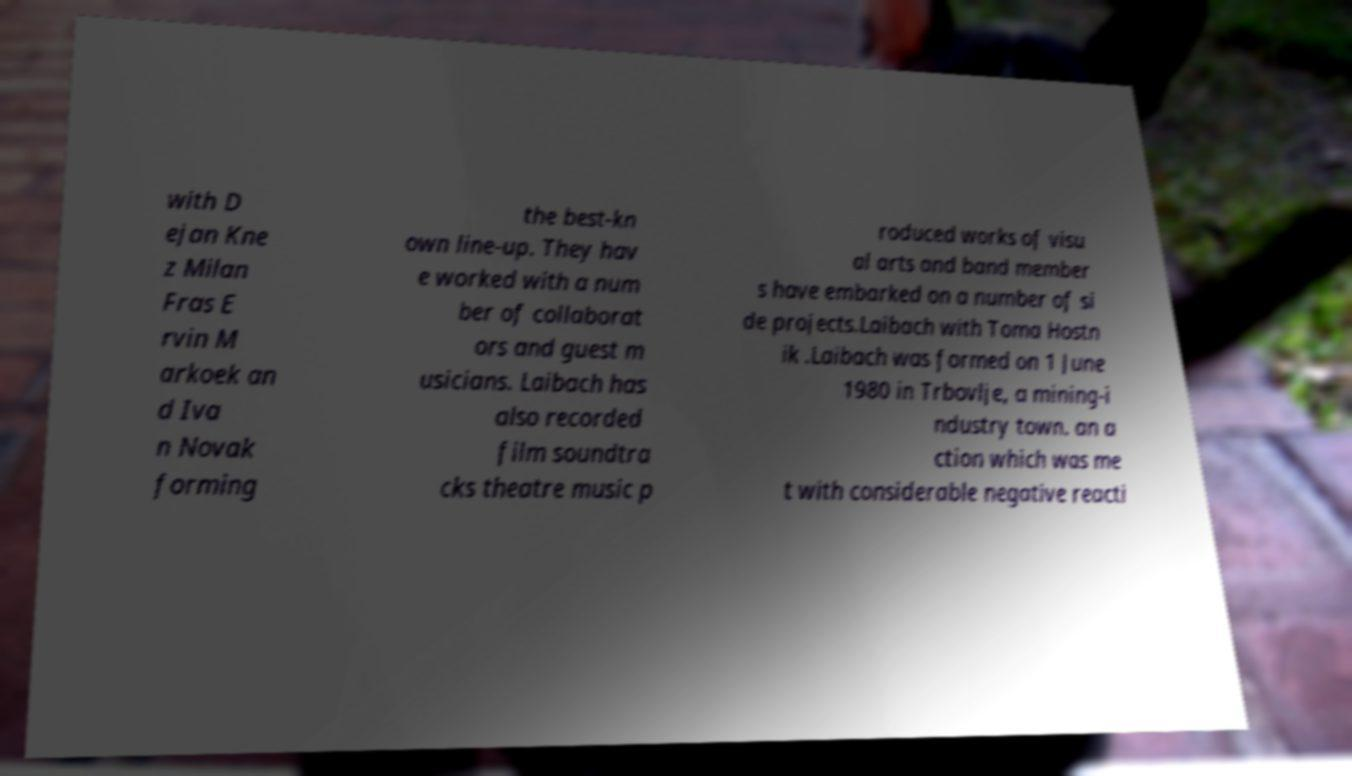I need the written content from this picture converted into text. Can you do that? with D ejan Kne z Milan Fras E rvin M arkoek an d Iva n Novak forming the best-kn own line-up. They hav e worked with a num ber of collaborat ors and guest m usicians. Laibach has also recorded film soundtra cks theatre music p roduced works of visu al arts and band member s have embarked on a number of si de projects.Laibach with Toma Hostn ik .Laibach was formed on 1 June 1980 in Trbovlje, a mining-i ndustry town. an a ction which was me t with considerable negative reacti 